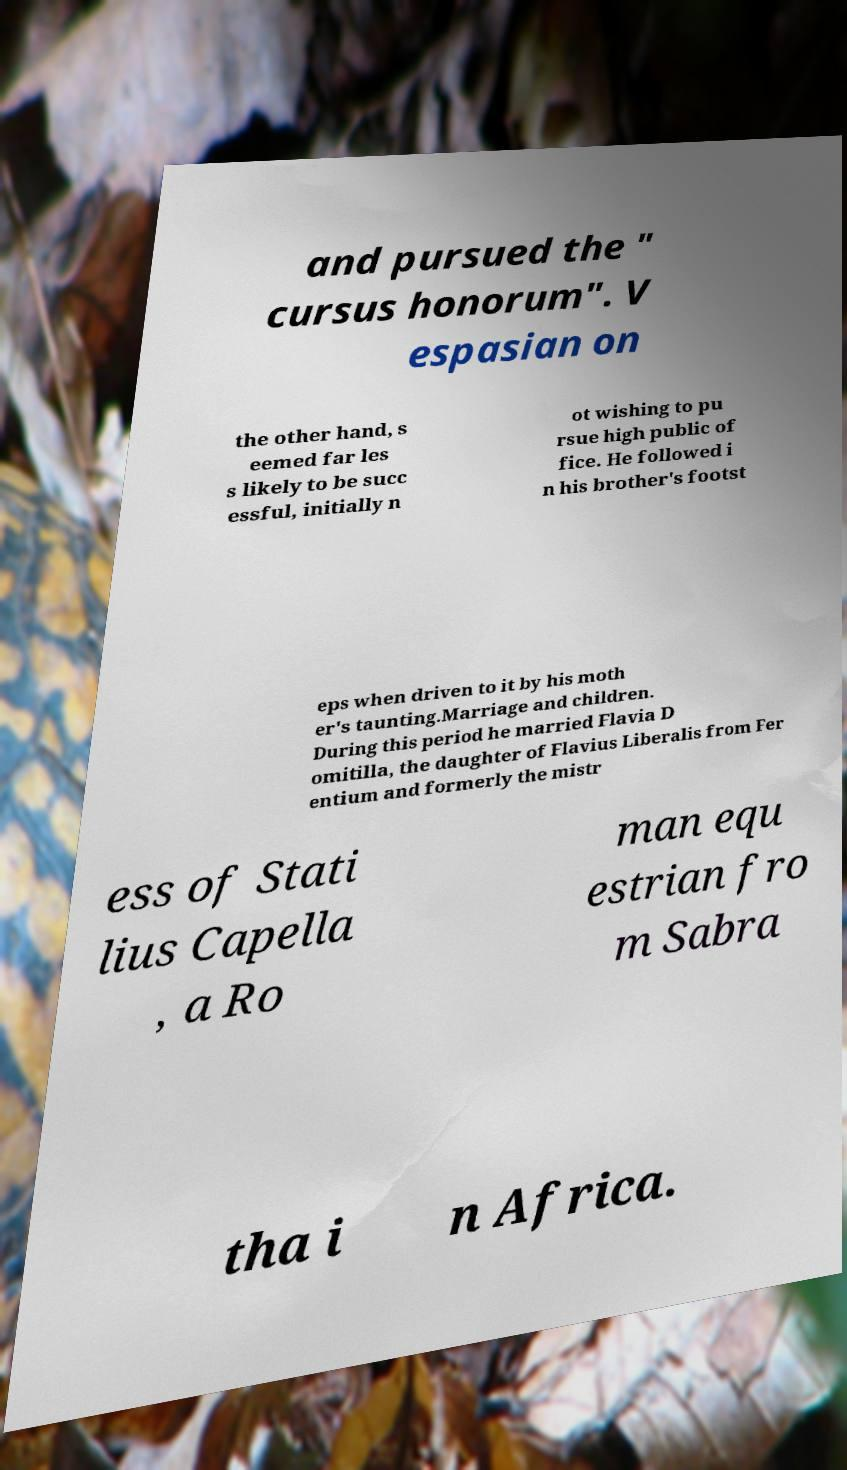I need the written content from this picture converted into text. Can you do that? and pursued the " cursus honorum". V espasian on the other hand, s eemed far les s likely to be succ essful, initially n ot wishing to pu rsue high public of fice. He followed i n his brother's footst eps when driven to it by his moth er's taunting.Marriage and children. During this period he married Flavia D omitilla, the daughter of Flavius Liberalis from Fer entium and formerly the mistr ess of Stati lius Capella , a Ro man equ estrian fro m Sabra tha i n Africa. 